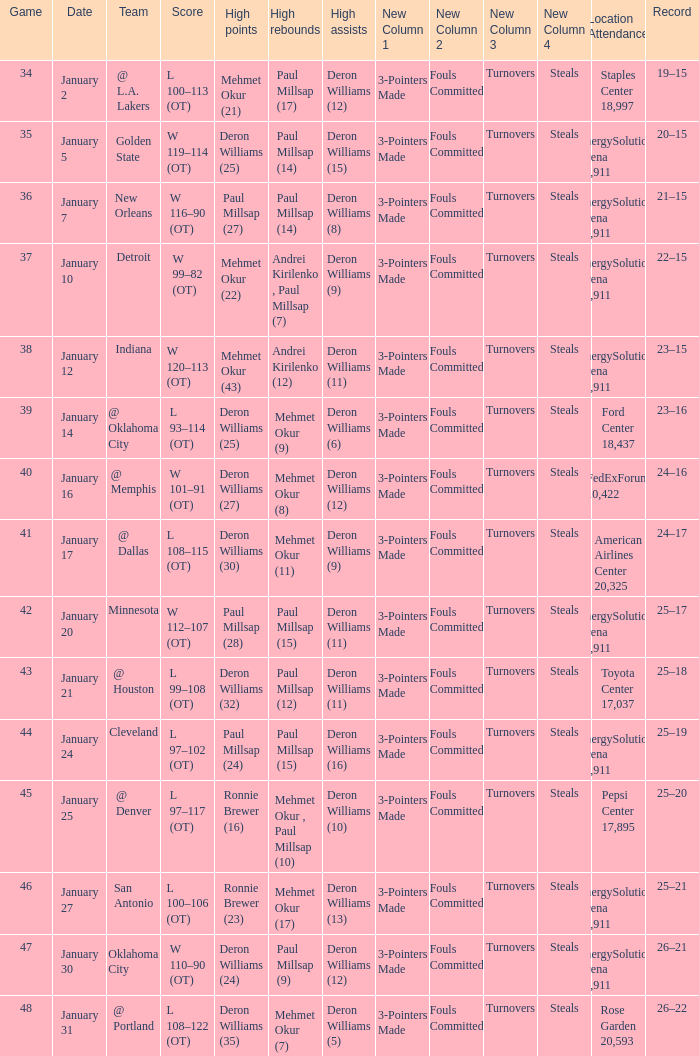What was the score of Game 48? L 108–122 (OT). 